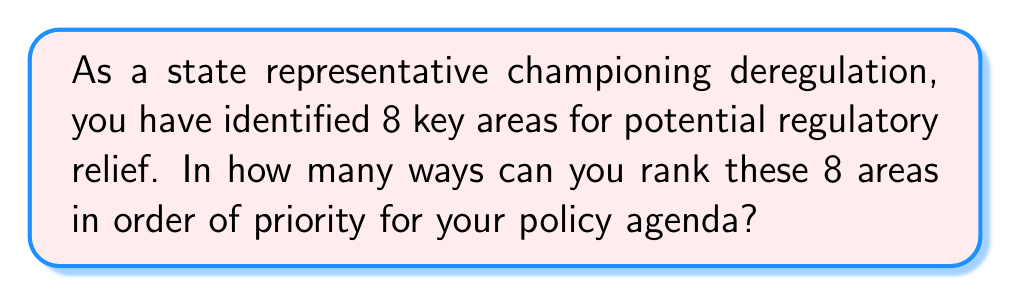Can you solve this math problem? To solve this problem, we need to understand that we're dealing with a permutation of 8 distinct items. Here's the step-by-step solution:

1) This is a straightforward permutation problem. We need to arrange 8 distinct items (deregulation areas) in a specific order.

2) The formula for permutations of n distinct objects is:

   $$P(n) = n!$$

   Where $n!$ represents the factorial of $n$.

3) In this case, $n = 8$, so we need to calculate $8!$

4) Let's expand this:
   
   $$8! = 8 \times 7 \times 6 \times 5 \times 4 \times 3 \times 2 \times 1$$

5) Calculating this out:
   
   $$8! = 40,320$$

Therefore, there are 40,320 ways to rank the 8 deregulation priorities.
Answer: 40,320 